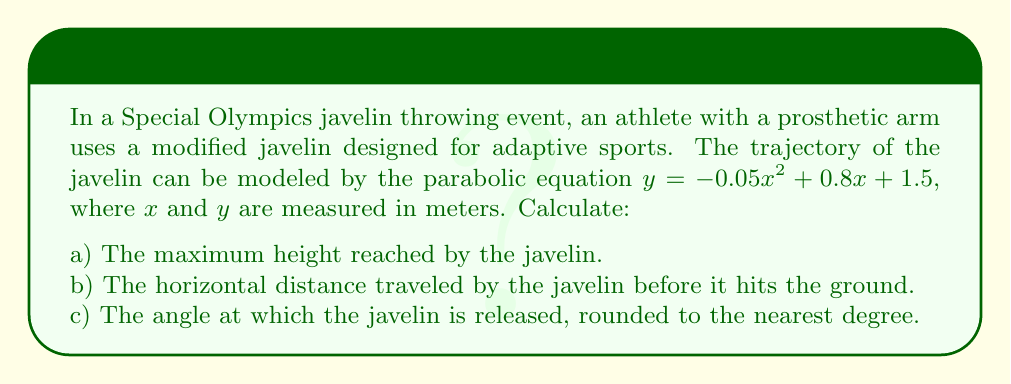Could you help me with this problem? Let's approach this problem step by step:

a) To find the maximum height, we need to find the vertex of the parabola. For a quadratic equation in the form $y = ax^2 + bx + c$, the x-coordinate of the vertex is given by $x = -\frac{b}{2a}$.

Here, $a = -0.05$, $b = 0.8$, and $c = 1.5$.

$x = -\frac{0.8}{2(-0.05)} = 8$ meters

To find the y-coordinate (maximum height), we substitute this x-value into the original equation:

$y = -0.05(8)^2 + 0.8(8) + 1.5$
$y = -0.05(64) + 6.4 + 1.5$
$y = -3.2 + 6.4 + 1.5 = 4.7$ meters

b) To find the horizontal distance, we need to find where the javelin hits the ground, which is where $y = 0$. We can solve this by using the quadratic formula:

$0 = -0.05x^2 + 0.8x + 1.5$

$ax^2 + bx + c = 0$, where $a = -0.05$, $b = 0.8$, and $c = 1.5$

$x = \frac{-b \pm \sqrt{b^2 - 4ac}}{2a}$

$x = \frac{-0.8 \pm \sqrt{0.8^2 - 4(-0.05)(1.5)}}{2(-0.05)}$

$x = \frac{-0.8 \pm \sqrt{0.64 + 0.3}}{-0.1} = \frac{-0.8 \pm \sqrt{0.94}}{-0.1}$

$x = \frac{-0.8 \pm 0.9695}{-0.1}$

This gives us two solutions: $x_1 = -1.695$ and $x_2 = 16.695$

Since negative distance doesn't make sense in this context, the javelin travels 16.695 meters horizontally.

c) To find the release angle, we need to calculate the slope of the trajectory at the point of release $(0, 1.5)$. The derivative of the function gives us the slope at any point:

$\frac{dy}{dx} = -0.1x + 0.8$

At $x = 0$, the slope is 0.8.

The angle of release $\theta$ is given by $\tan(\theta) = 0.8$

$\theta = \arctan(0.8) \approx 38.66°$

Rounded to the nearest degree, this is 39°.
Answer: a) The maximum height reached by the javelin is 4.7 meters.
b) The horizontal distance traveled by the javelin is 16.695 meters.
c) The angle at which the javelin is released is 39°. 